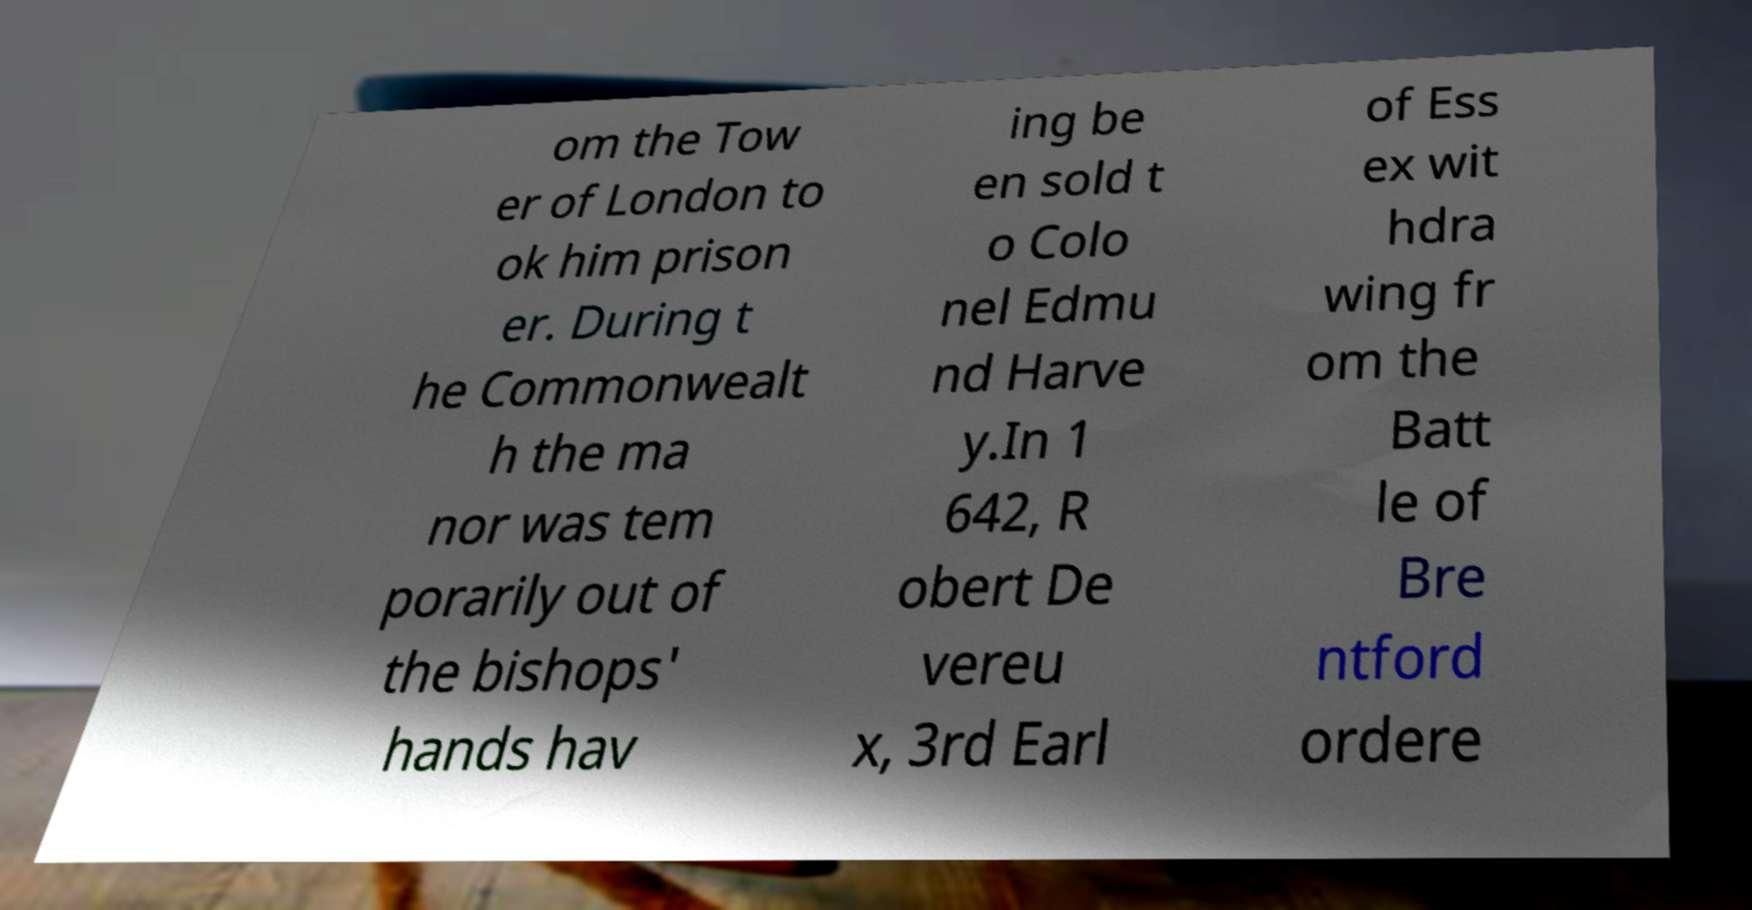Can you read and provide the text displayed in the image?This photo seems to have some interesting text. Can you extract and type it out for me? om the Tow er of London to ok him prison er. During t he Commonwealt h the ma nor was tem porarily out of the bishops' hands hav ing be en sold t o Colo nel Edmu nd Harve y.In 1 642, R obert De vereu x, 3rd Earl of Ess ex wit hdra wing fr om the Batt le of Bre ntford ordere 